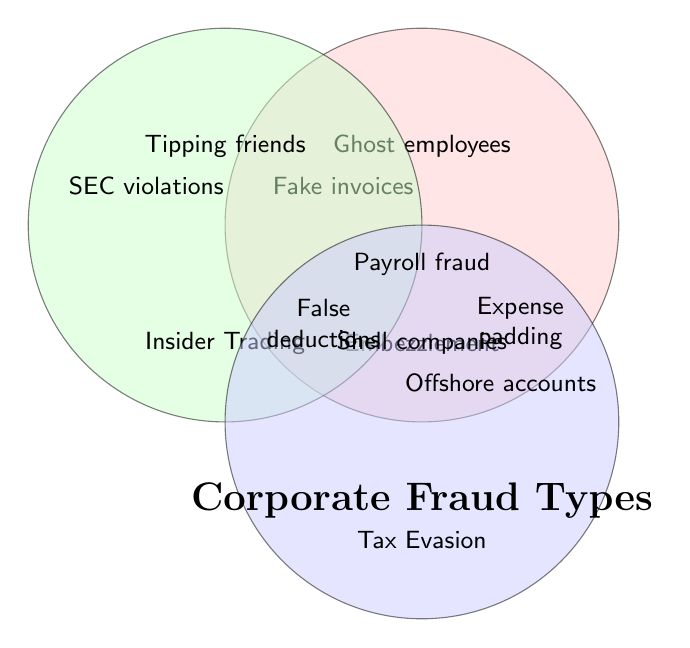What are the three types of corporate fraud shown in the diagram? The diagram is titled "Corporate Fraud Types" and shows three main categories intersecting in a Venn Diagram: Embezzlement, Insider Trading, and Tax Evasion.
Answer: Embezzlement, Insider Trading, Tax Evasion Which type of fraud does "Fake invoices" fall under? "Fake invoices" is located within the circle labeled "Embezzlement" in the diagram.
Answer: Embezzlement Name one type of fraud that is unique to Insider Trading. "SEC violations" is located within the circle labeled "Insider Trading" and is not shared with any other category.
Answer: SEC violations Is "Shell companies" associated with both Embezzlement and Tax Evasion? "Shell companies" is located within the Tax Evasion circle and does not overlap with Embezzlement.
Answer: No Where would you find "Tipping friends" in the Venn Diagram? "Tipping friends" is located within the Insider Trading circle.
Answer: Insider Trading Identify a type of fraud that is shared between all three categories of Embezzlement, Insider Trading, and Tax Evasion. No common type of fraud is shared among all three categories as per the given data and diagram.
Answer: None Which type of fraud operations are shared between Embezzlement and Tax Evasion? "Expense padding" and "False deductions" are located in the overlapping sections between Embezzlement and Tax Evasion.
Answer: Expense padding, False deductions Is "Payroll fraud" associated only with Embezzlement or shared with any other category? "Payroll fraud" is located within the Embezzlement circle and does not overlap with any other category.
Answer: Embezzlement Are there any types of fraud listed that overlap between Insider Trading and Tax Evasion? The diagram does not show any types of fraud that overlap exclusively between Insider Trading and Tax Evasion.
Answer: No Which type of fraud does "Manipulating stock prices" belong to, and are there any intersections with other fraud categories? "Manipulating stock prices" falls under Insider Trading and does not intersect with other fraud categories.
Answer: Insider Trading 